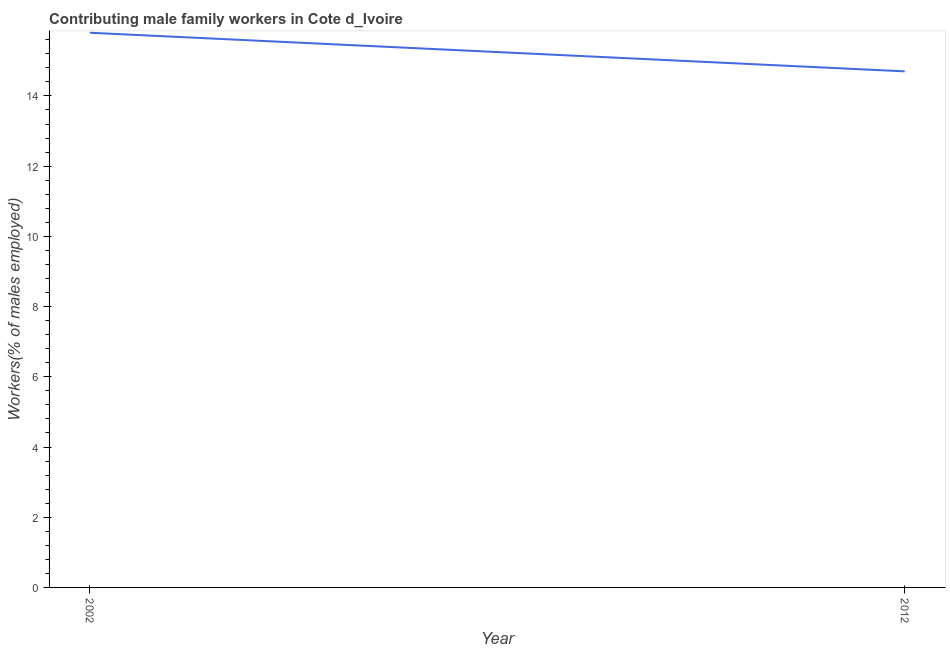What is the contributing male family workers in 2012?
Your response must be concise. 14.7. Across all years, what is the maximum contributing male family workers?
Provide a short and direct response. 15.8. Across all years, what is the minimum contributing male family workers?
Offer a terse response. 14.7. In which year was the contributing male family workers minimum?
Your answer should be compact. 2012. What is the sum of the contributing male family workers?
Offer a terse response. 30.5. What is the difference between the contributing male family workers in 2002 and 2012?
Offer a terse response. 1.1. What is the average contributing male family workers per year?
Offer a terse response. 15.25. What is the median contributing male family workers?
Your answer should be very brief. 15.25. In how many years, is the contributing male family workers greater than 6 %?
Offer a very short reply. 2. What is the ratio of the contributing male family workers in 2002 to that in 2012?
Offer a terse response. 1.07. Does the contributing male family workers monotonically increase over the years?
Provide a short and direct response. No. What is the difference between two consecutive major ticks on the Y-axis?
Your answer should be very brief. 2. What is the title of the graph?
Provide a succinct answer. Contributing male family workers in Cote d_Ivoire. What is the label or title of the X-axis?
Your answer should be compact. Year. What is the label or title of the Y-axis?
Your response must be concise. Workers(% of males employed). What is the Workers(% of males employed) of 2002?
Provide a succinct answer. 15.8. What is the Workers(% of males employed) in 2012?
Offer a very short reply. 14.7. What is the difference between the Workers(% of males employed) in 2002 and 2012?
Keep it short and to the point. 1.1. What is the ratio of the Workers(% of males employed) in 2002 to that in 2012?
Make the answer very short. 1.07. 